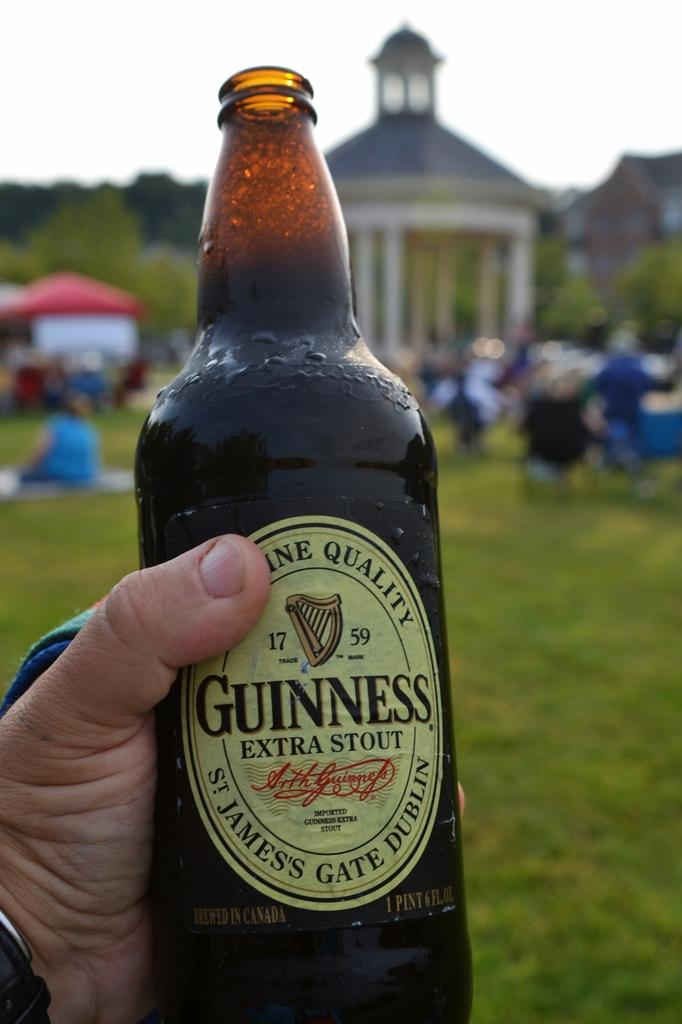What is contained in the bottle that is visible in the image? There is a drink in the bottle that is visible in the image. How is the bottle being held in the image? The bottle is held by a person's hand in the image. What can be seen in the background of the image? There is a house, people, trees, the sky, and grass visible in the background of the image. What is the overall quality of the image? The image is blurry. What type of car is parked in front of the house in the image? There is no car present in the image; only a house, people, trees, the sky, and grass are visible in the background. 